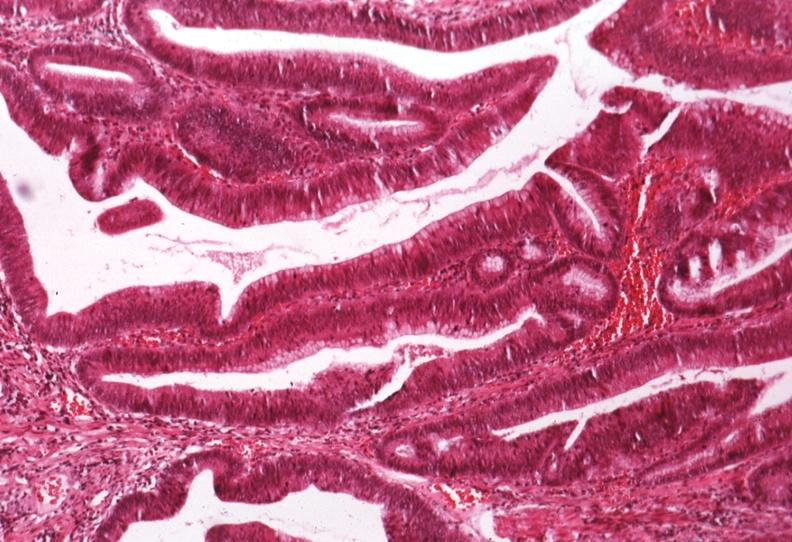s gastrointestinal present?
Answer the question using a single word or phrase. Yes 